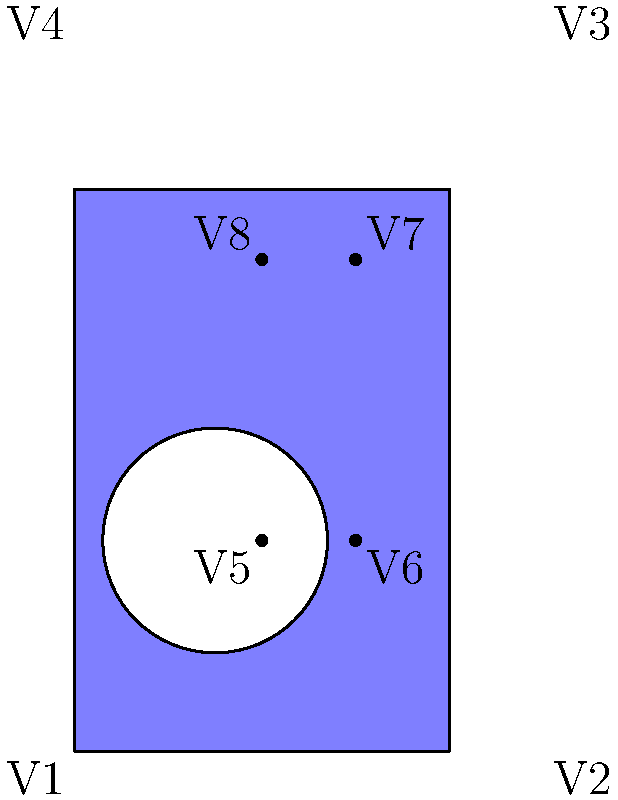Ultraman's Color Timer is often represented as a blue rectangular surface with a circular hole. If we simplify this shape as shown in the diagram, calculate the Euler characteristic (χ) of this surface. How does this relate to the genus of the surface? Let's approach this step-by-step:

1) The Euler characteristic (χ) is calculated using the formula:
   $$χ = V - E + F$$
   where V is the number of vertices, E is the number of edges, and F is the number of faces.

2) In this diagram:
   - Vertices (V): We have 8 vertices (V1 to V8)
   - Edges (E): We have 12 edges (4 outer edges, 4 inner edges, and 4 connecting edges)
   - Faces (F): We have 2 faces (the blue area and the white circular hole)

3) Plugging these values into the formula:
   $$χ = 8 - 12 + 2 = -2$$

4) For a closed orientable surface, the Euler characteristic is related to the genus (g) by the formula:
   $$χ = 2 - 2g$$

5) Solving for g:
   $$-2 = 2 - 2g$$
   $$2g = 4$$
   $$g = 2$$

6) This means the surface has a genus of 2, which is equivalent to a double torus or a surface with two "handles".
Answer: χ = -2; genus = 2 